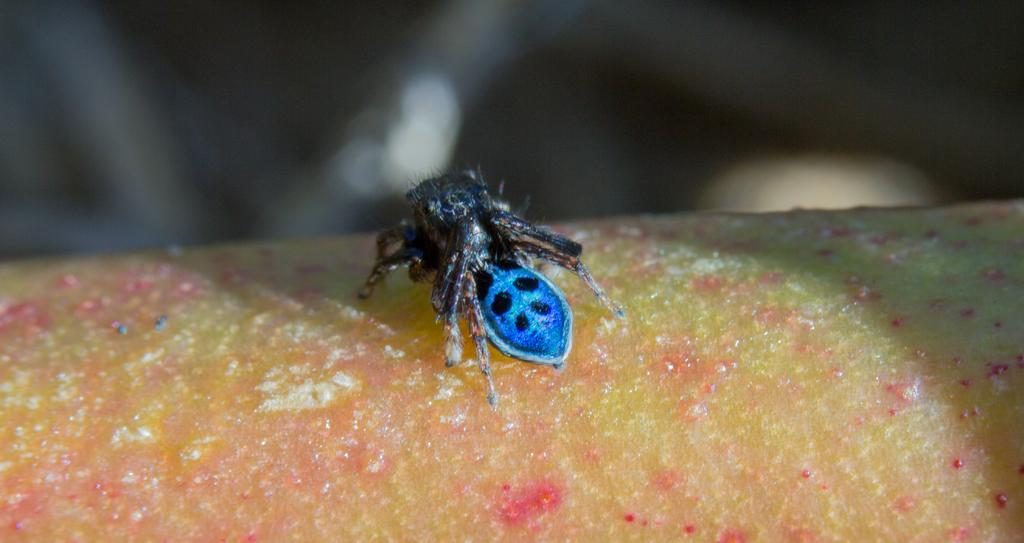What type of creature can be seen in the image? There is an insect in the image. What is the insect doing or located on in the image? The insect is on a food item. Can you describe the background of the image? The background of the image is blurred. What type of doll is present in the image? There is no doll present in the image; it features an insect on a food item with a blurred background. 